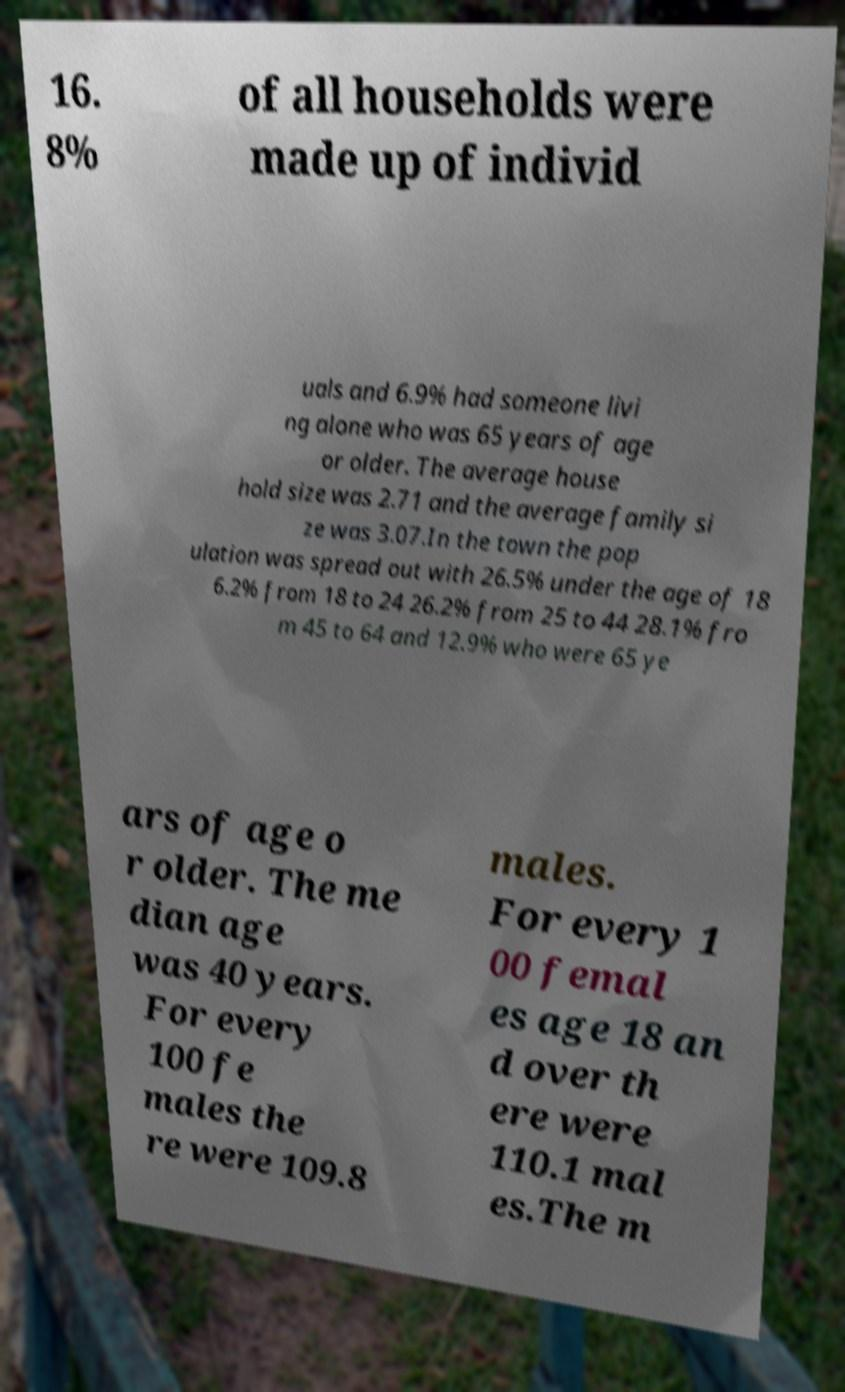Can you accurately transcribe the text from the provided image for me? 16. 8% of all households were made up of individ uals and 6.9% had someone livi ng alone who was 65 years of age or older. The average house hold size was 2.71 and the average family si ze was 3.07.In the town the pop ulation was spread out with 26.5% under the age of 18 6.2% from 18 to 24 26.2% from 25 to 44 28.1% fro m 45 to 64 and 12.9% who were 65 ye ars of age o r older. The me dian age was 40 years. For every 100 fe males the re were 109.8 males. For every 1 00 femal es age 18 an d over th ere were 110.1 mal es.The m 